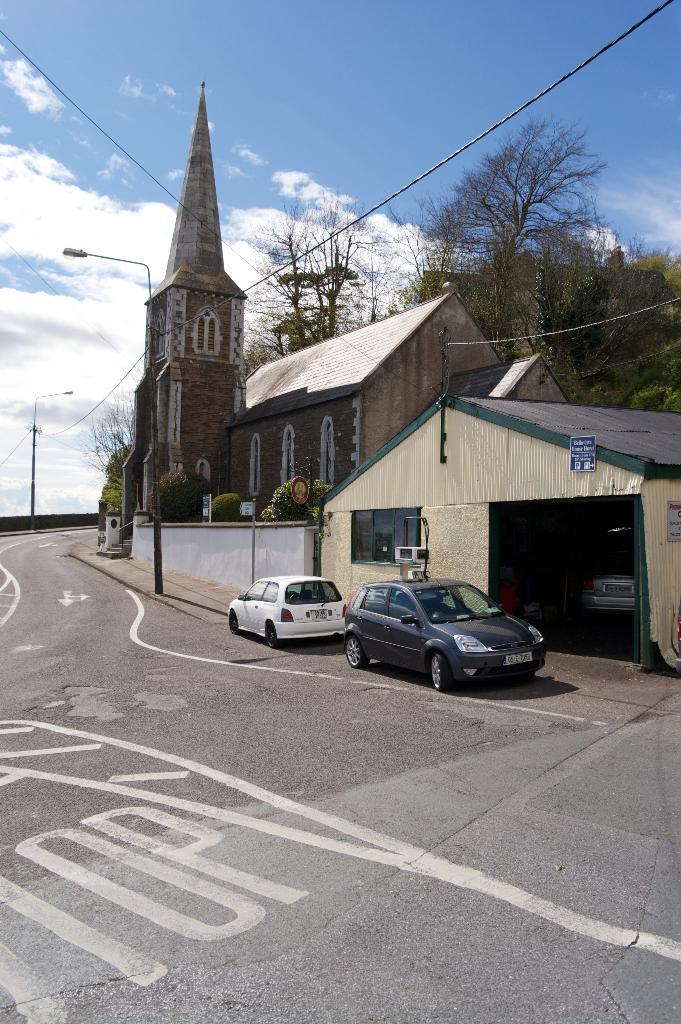What types of objects can be seen in the image? There are vehicles, a house, a shed, boards, poles, lights, and cables in the image. What type of structure is present in the image? There is a house in the image. What other structures can be seen in the image? There is a shed in the image. What type of vegetation is visible in the image? There are trees in the image. What is visible in the background of the image? The sky is visible in the background of the image. What year is depicted in the image? The image does not depict a specific year; it is a still image of various objects and structures. Can you tell me how many people are swimming in the image? There are no people swimming in the image; it does not depict any water or swimming activities. 